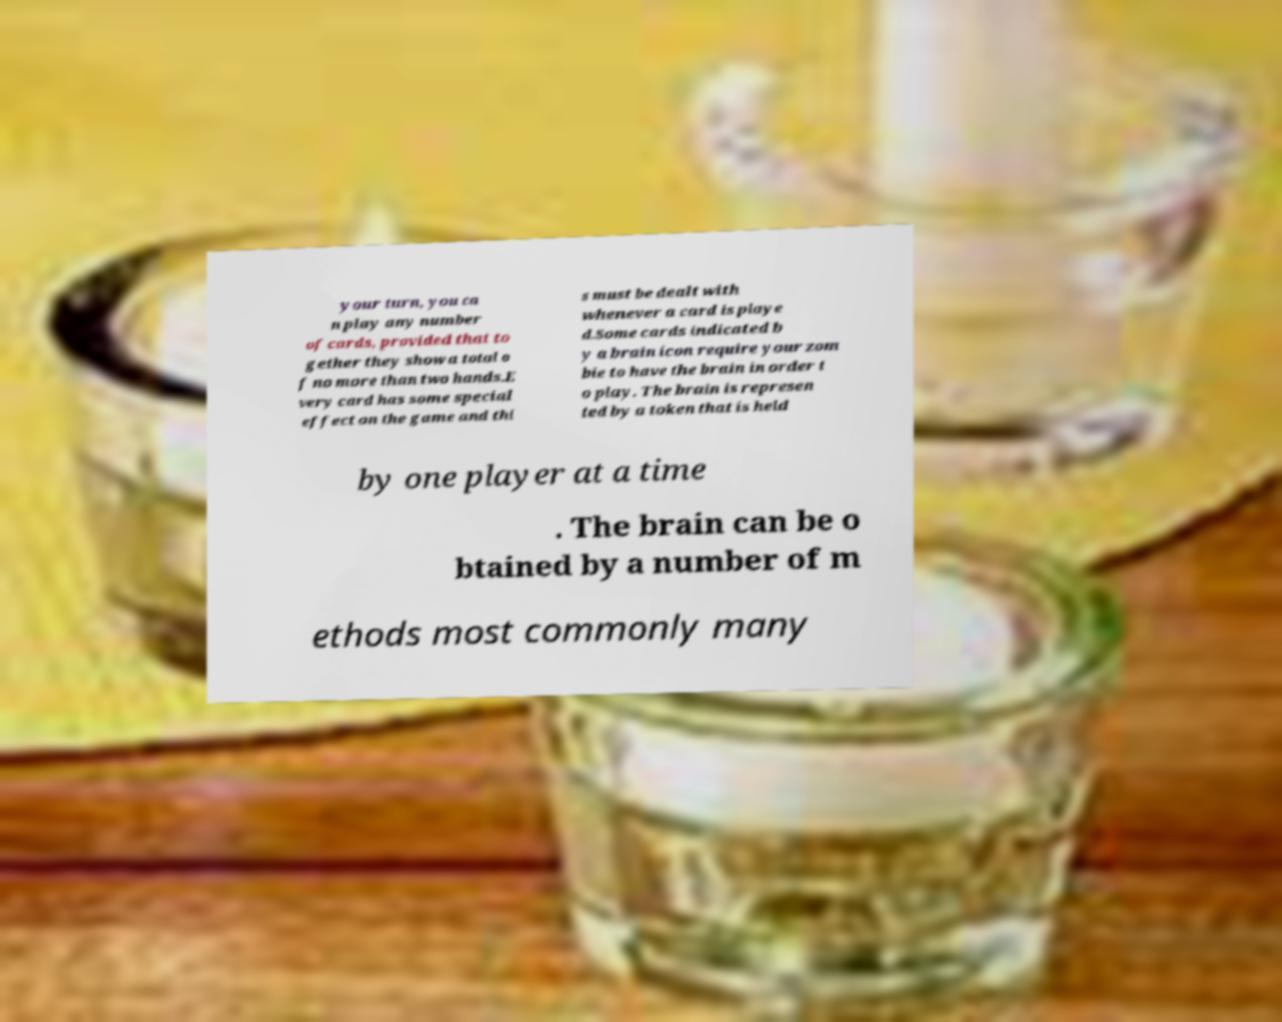What messages or text are displayed in this image? I need them in a readable, typed format. your turn, you ca n play any number of cards, provided that to gether they show a total o f no more than two hands.E very card has some special effect on the game and thi s must be dealt with whenever a card is playe d.Some cards indicated b y a brain icon require your zom bie to have the brain in order t o play. The brain is represen ted by a token that is held by one player at a time . The brain can be o btained by a number of m ethods most commonly many 